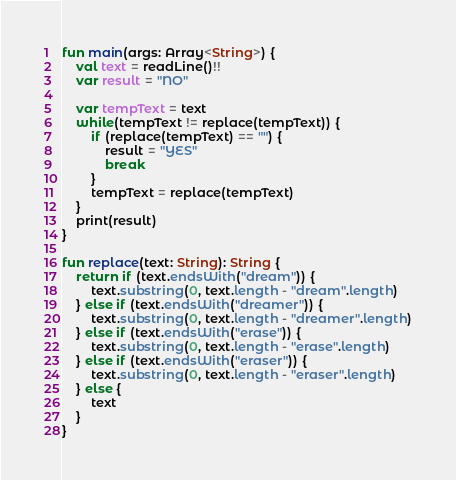Convert code to text. <code><loc_0><loc_0><loc_500><loc_500><_Kotlin_>fun main(args: Array<String>) {
    val text = readLine()!!
    var result = "NO"

    var tempText = text
    while(tempText != replace(tempText)) {
        if (replace(tempText) == "") {
            result = "YES"
            break
        }
        tempText = replace(tempText)
    }
    print(result)
}

fun replace(text: String): String {
    return if (text.endsWith("dream")) {
        text.substring(0, text.length - "dream".length)
    } else if (text.endsWith("dreamer")) {
        text.substring(0, text.length - "dreamer".length)
    } else if (text.endsWith("erase")) {
        text.substring(0, text.length - "erase".length)
    } else if (text.endsWith("eraser")) {
        text.substring(0, text.length - "eraser".length)
    } else {
        text
    }
}</code> 